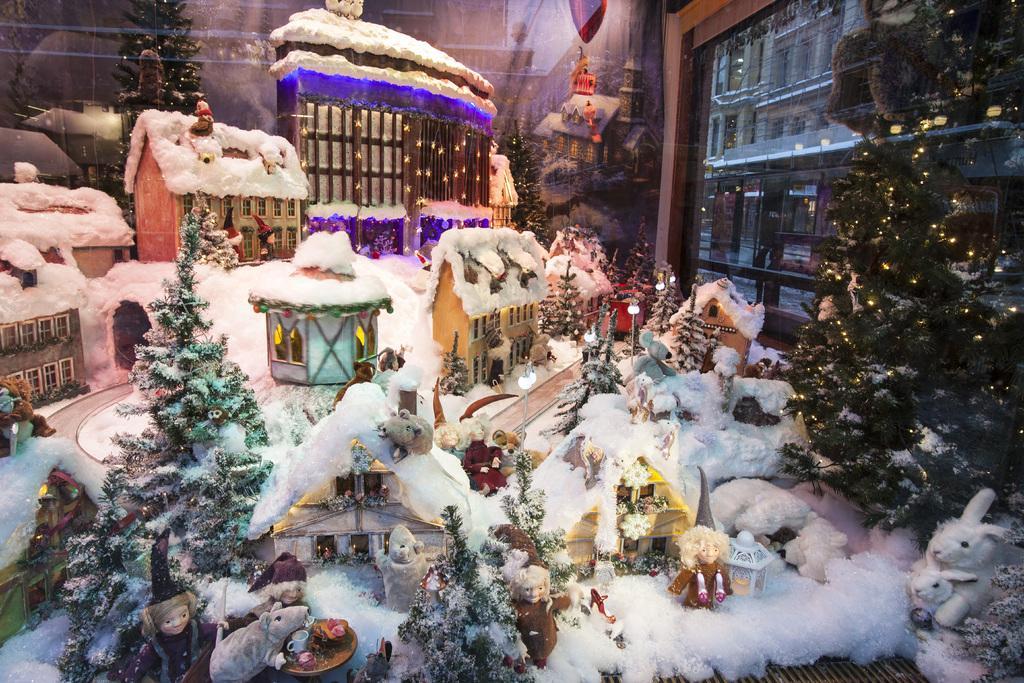Please provide a concise description of this image. In this picture we can see a few toys, decorative items, lights, Christmas trees, glass objects and other objects. We can see a building and a few things through a glass object. 